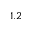Convert formula to latex. <formula><loc_0><loc_0><loc_500><loc_500>1 . 2</formula> 